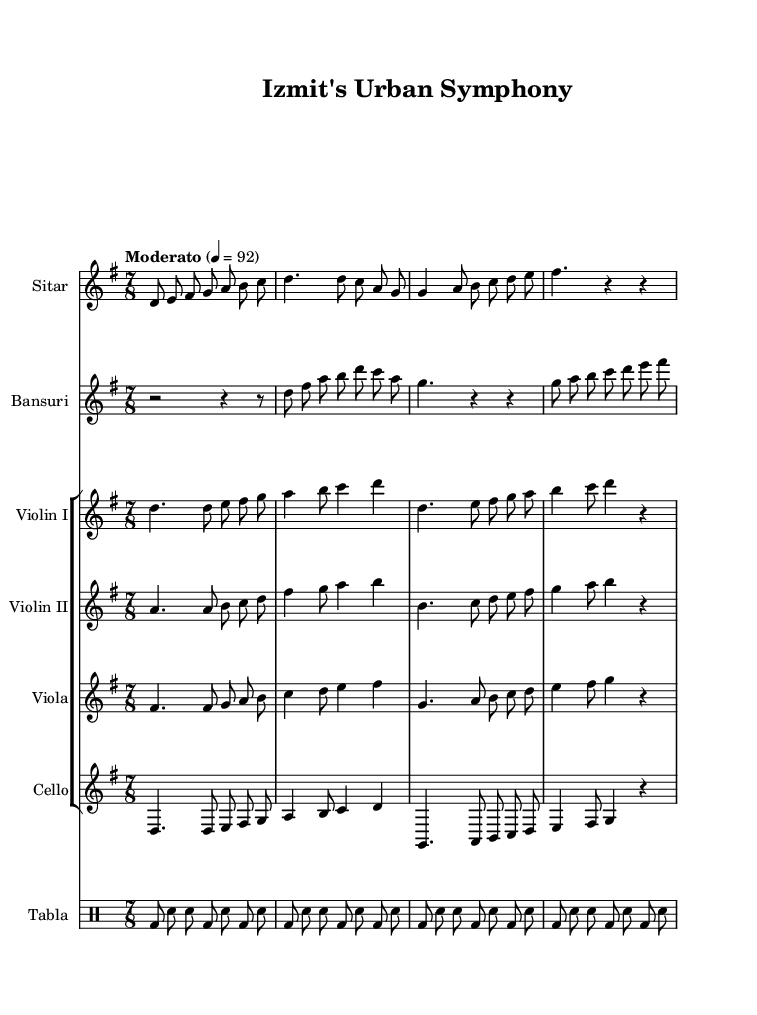What is the key signature of this music? The key signature is D mixolydian, which is indicated by the presence of C# in the context of the D scale. Since it does not show any flats or additional sharps, it confirms the key signature.
Answer: D mixolydian What is the time signature of this music? The time signature is 7/8, which can be observed at the beginning of the score in the time signature indicator. This indicates that each measure contains seven eighth notes.
Answer: 7/8 What is the tempo marking of this music? The tempo marking is "Moderato," as specified at the beginning of the score, typically indicating a moderately fast speed. Additionally, the numbers "4 = 92" show the beat per minute.
Answer: Moderato Which instruments are included in this composition? The composition features Sitar, Bansuri, Violin I, Violin II, Viola, Cello, and Tabla. This can be determined by looking at the staff names listed at the beginning of each staff in the sheet music.
Answer: Sitar, Bansuri, Violin I, Violin II, Viola, Cello, Tabla How many measures are in the Sitar part? The Sitar part consists of 4 measures, as one can count the vertical bar lines which indicate the beginning and end of each measure. Each part of the staff is divided into these measures.
Answer: 4 What rhythmic pattern is used primarily in the Tabla part? The rhythmic pattern primarily consists of a repeating phrase of bass drum (bd) and snare drum (sn) in alternating eighth notes. This pattern is recognizable throughout the Tabla section of the composition.
Answer: bd sn pattern Does this composition reflect a fusion of Western and Indian music styles? Yes, the combination of instruments typical in Indian classical music, such as the Sitar and Tabla, with string instruments like the Violin and Viola, indicates a blending of musical traditions, thus representing a fusion.
Answer: Yes 